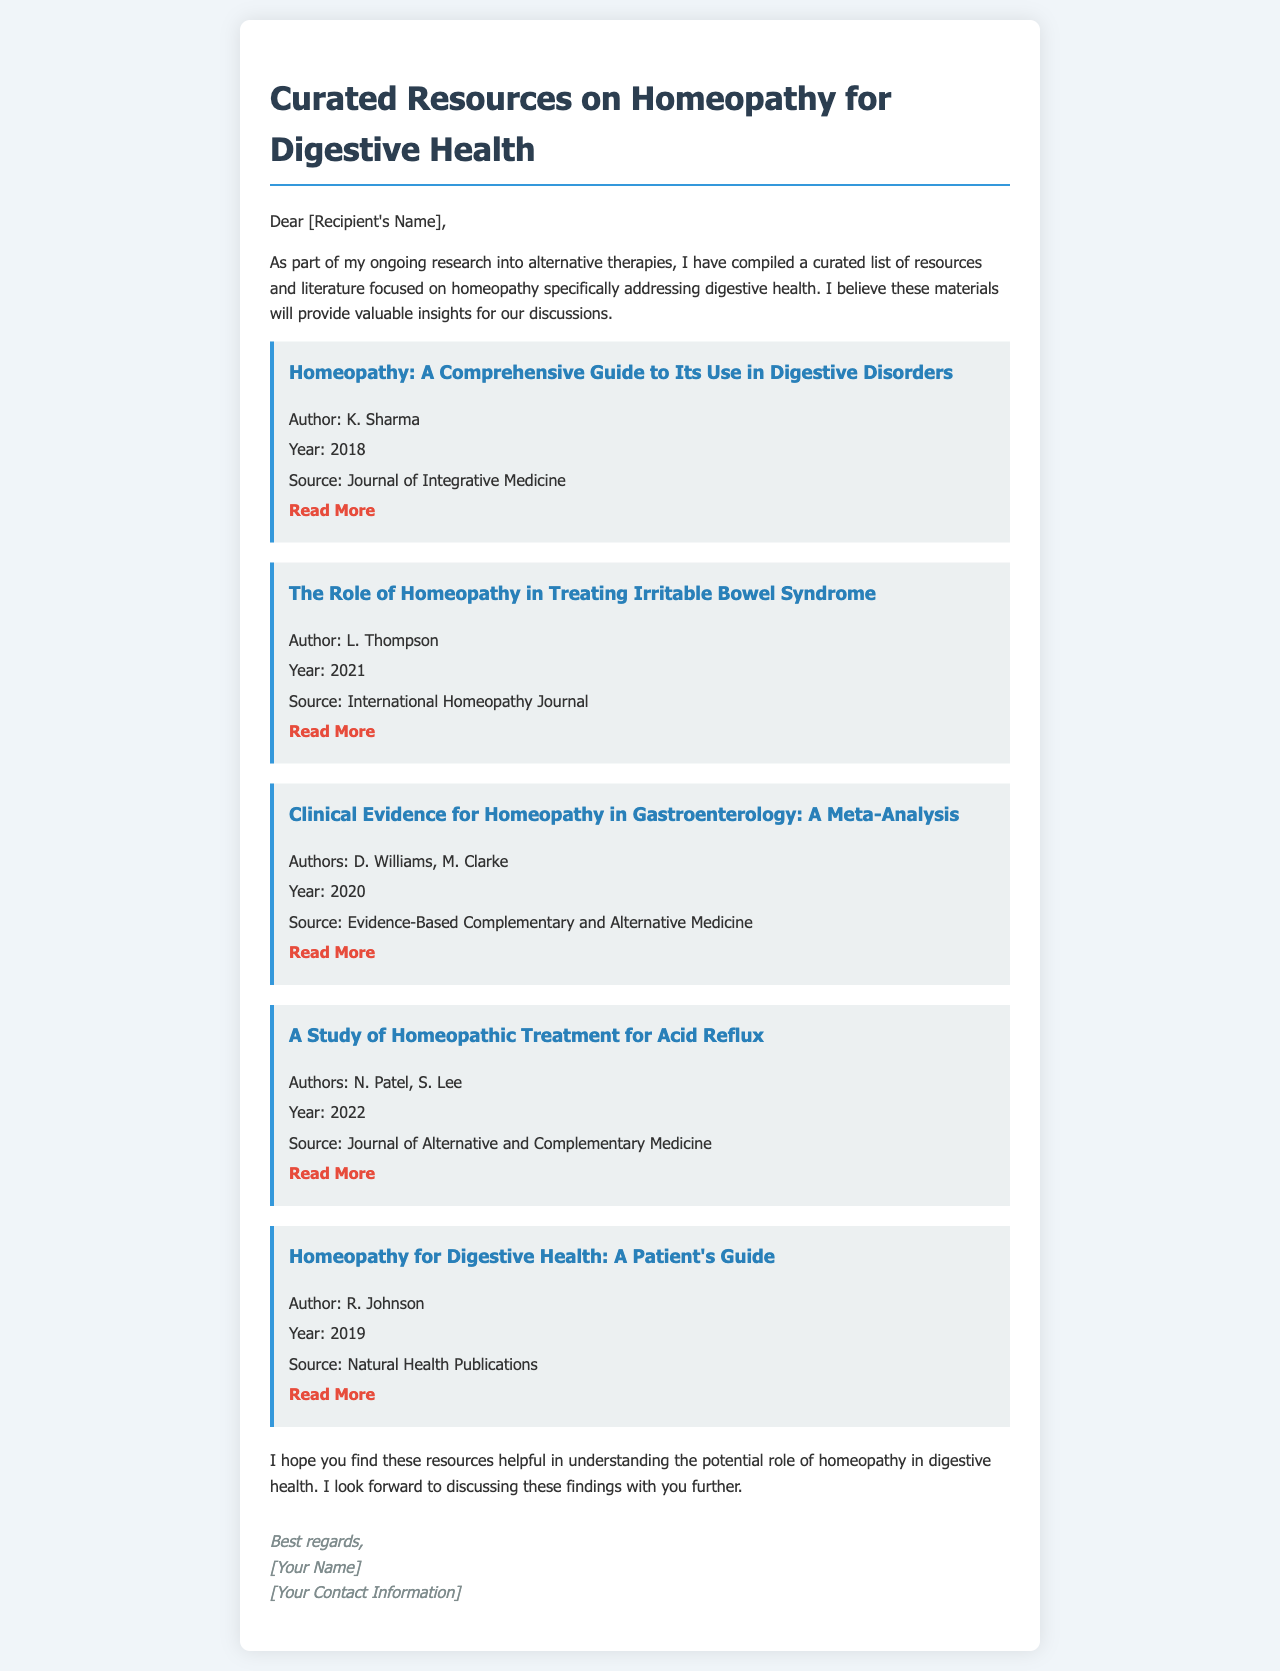What is the title of the first resource listed? The title of the first resource is presented in a heading format at the top of its section.
Answer: Homeopathy: A Comprehensive Guide to Its Use in Digestive Disorders Who is the author of the resource on Irritable Bowel Syndrome? The author's name is indicated in the details of the resource section related to Irritable Bowel Syndrome.
Answer: L. Thompson What year was the meta-analysis on homeopathy published? The year of publication is mentioned clearly in the resource details focusing on the clinical evidence.
Answer: 2020 How many authors contributed to the study on Acid Reflux? The number of authors is found in the authors section of the respective resource, indicating the count.
Answer: 2 What is the primary topic of the email? The primary topic of the email is summarized in the opening paragraph, highlighting its focus on a specific field.
Answer: Homeopathy for Digestive Health What type of publication is "Natural Health Publications"? This information can be inferred from the details provided about the resource.
Answer: Publisher What is the purpose of this email? The purpose of the email is expressed in the introduction, focusing on sharing valuable materials for a particular aim.
Answer: Sharing resources on homeopathy Which resource focuses specifically on a patient's perspective? The title of the resource is highlighted to indicate its focus from a patient's viewpoint.
Answer: Homeopathy for Digestive Health: A Patient's Guide What color is used for the signature in the email? The color of the signature is described in the style section of the email's CSS.
Answer: #7f8c8d 